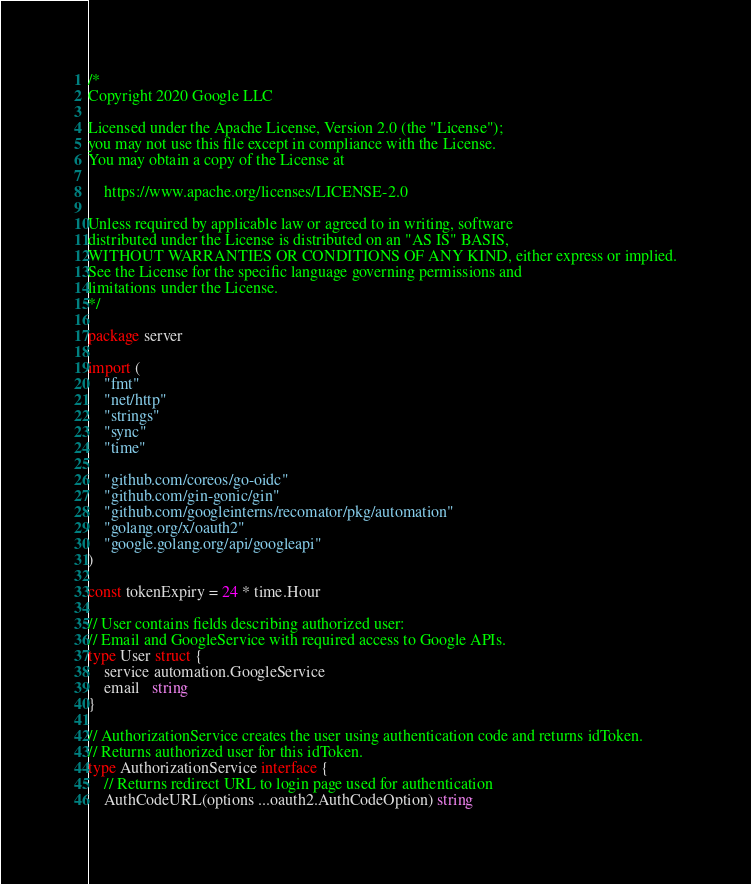Convert code to text. <code><loc_0><loc_0><loc_500><loc_500><_Go_>/*
Copyright 2020 Google LLC

Licensed under the Apache License, Version 2.0 (the "License");
you may not use this file except in compliance with the License.
You may obtain a copy of the License at

    https://www.apache.org/licenses/LICENSE-2.0

Unless required by applicable law or agreed to in writing, software
distributed under the License is distributed on an "AS IS" BASIS,
WITHOUT WARRANTIES OR CONDITIONS OF ANY KIND, either express or implied.
See the License for the specific language governing permissions and
limitations under the License.
*/

package server

import (
	"fmt"
	"net/http"
	"strings"
	"sync"
	"time"

	"github.com/coreos/go-oidc"
	"github.com/gin-gonic/gin"
	"github.com/googleinterns/recomator/pkg/automation"
	"golang.org/x/oauth2"
	"google.golang.org/api/googleapi"
)

const tokenExpiry = 24 * time.Hour

// User contains fields describing authorized user:
// Email and GoogleService with required access to Google APIs.
type User struct {
	service automation.GoogleService
	email   string
}

// AuthorizationService creates the user using authentication code and returns idToken.
// Returns authorized user for this idToken.
type AuthorizationService interface {
	// Returns redirect URL to login page used for authentication
	AuthCodeURL(options ...oauth2.AuthCodeOption) string</code> 